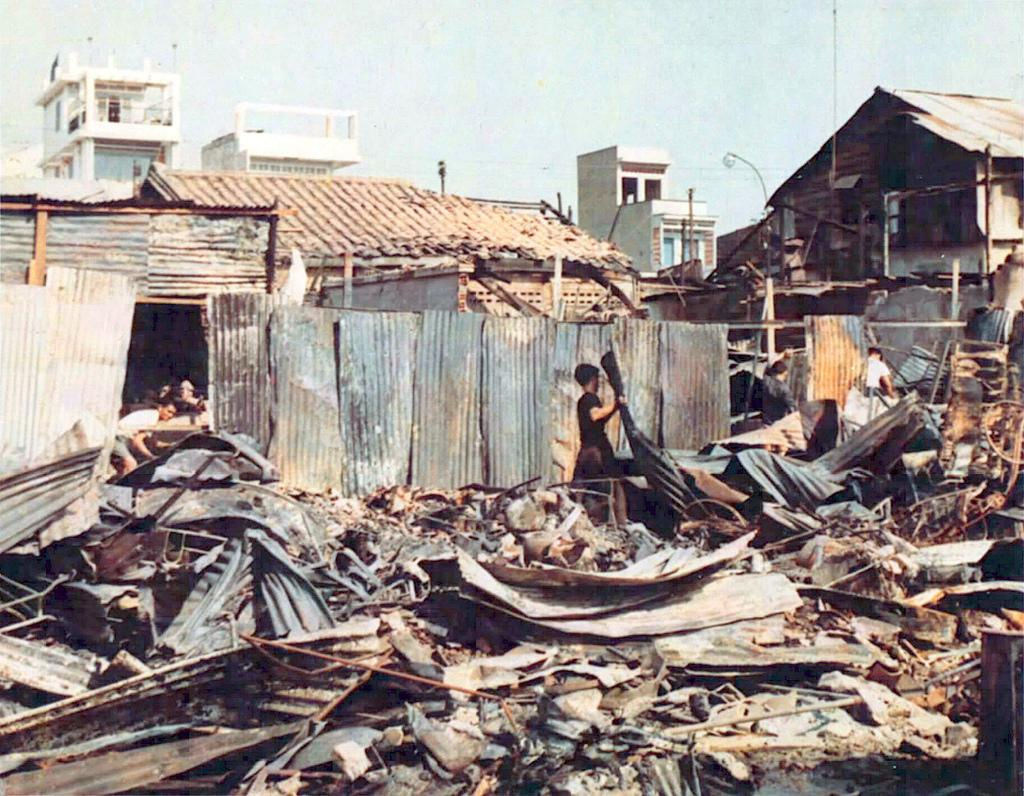Who is the main subject in the image? There is a boy in the middle of the image. What is the boy holding in the image? The boy is holding an iron piece. What can be seen on the right side of the image? There are collapsed houses on the right side of the image. What type of cart is being used to transport the trains in the image? There are no trains or carts present in the image. 